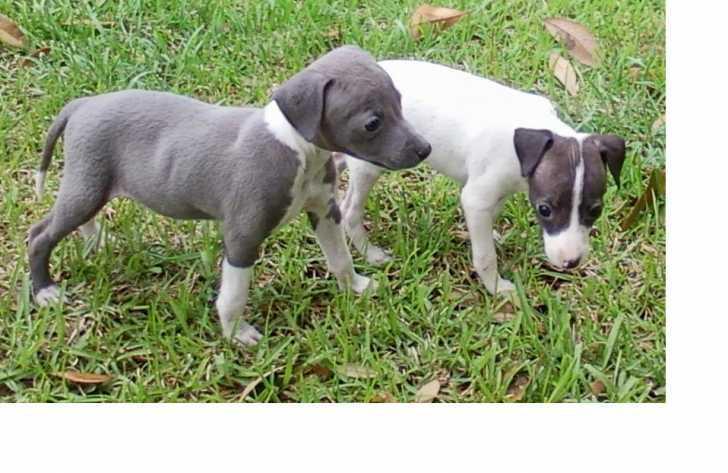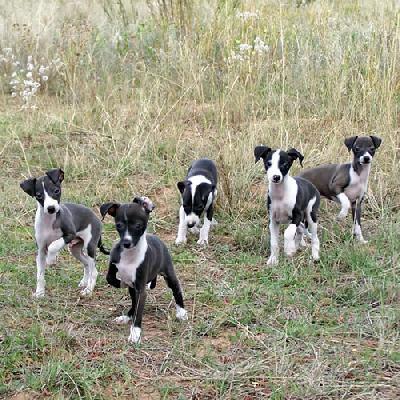The first image is the image on the left, the second image is the image on the right. Given the left and right images, does the statement "The left image contains exactly one dog." hold true? Answer yes or no. No. The first image is the image on the left, the second image is the image on the right. Evaluate the accuracy of this statement regarding the images: "All dogs in the image pair are facing the same direction.". Is it true? Answer yes or no. No. 